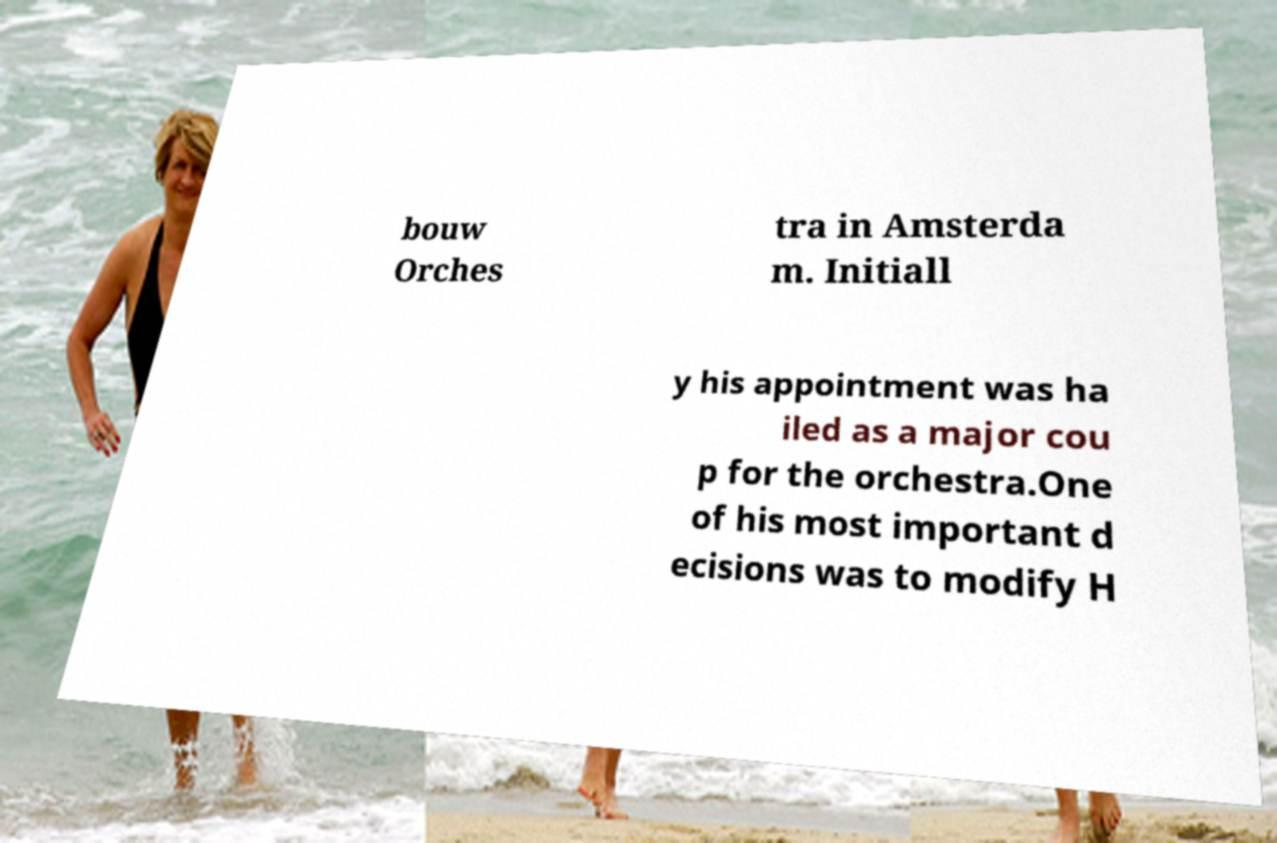Can you read and provide the text displayed in the image?This photo seems to have some interesting text. Can you extract and type it out for me? bouw Orches tra in Amsterda m. Initiall y his appointment was ha iled as a major cou p for the orchestra.One of his most important d ecisions was to modify H 